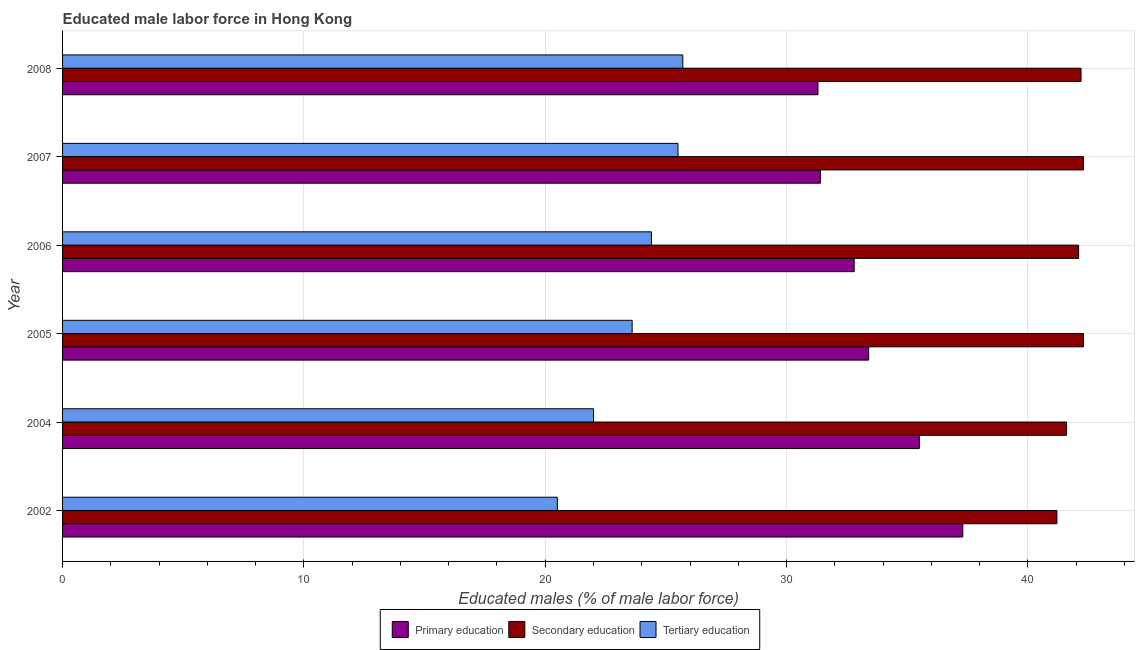How many different coloured bars are there?
Keep it short and to the point. 3. How many bars are there on the 5th tick from the top?
Offer a terse response. 3. How many bars are there on the 5th tick from the bottom?
Your answer should be compact. 3. What is the percentage of male labor force who received primary education in 2007?
Offer a terse response. 31.4. Across all years, what is the maximum percentage of male labor force who received primary education?
Ensure brevity in your answer.  37.3. Across all years, what is the minimum percentage of male labor force who received secondary education?
Provide a short and direct response. 41.2. In which year was the percentage of male labor force who received secondary education maximum?
Offer a very short reply. 2005. In which year was the percentage of male labor force who received primary education minimum?
Ensure brevity in your answer.  2008. What is the total percentage of male labor force who received secondary education in the graph?
Provide a short and direct response. 251.7. What is the difference between the percentage of male labor force who received tertiary education in 2002 and that in 2007?
Your answer should be compact. -5. What is the difference between the percentage of male labor force who received secondary education in 2004 and the percentage of male labor force who received tertiary education in 2006?
Your answer should be compact. 17.2. What is the average percentage of male labor force who received tertiary education per year?
Your answer should be compact. 23.62. In the year 2004, what is the difference between the percentage of male labor force who received primary education and percentage of male labor force who received secondary education?
Give a very brief answer. -6.1. In how many years, is the percentage of male labor force who received secondary education greater than 30 %?
Provide a succinct answer. 6. What is the ratio of the percentage of male labor force who received primary education in 2005 to that in 2007?
Give a very brief answer. 1.06. Is the percentage of male labor force who received tertiary education in 2005 less than that in 2007?
Provide a short and direct response. Yes. What is the difference between the highest and the lowest percentage of male labor force who received secondary education?
Ensure brevity in your answer.  1.1. In how many years, is the percentage of male labor force who received primary education greater than the average percentage of male labor force who received primary education taken over all years?
Keep it short and to the point. 2. What does the 2nd bar from the bottom in 2008 represents?
Offer a very short reply. Secondary education. Is it the case that in every year, the sum of the percentage of male labor force who received primary education and percentage of male labor force who received secondary education is greater than the percentage of male labor force who received tertiary education?
Offer a terse response. Yes. How many bars are there?
Give a very brief answer. 18. Are all the bars in the graph horizontal?
Give a very brief answer. Yes. How many years are there in the graph?
Your answer should be very brief. 6. What is the difference between two consecutive major ticks on the X-axis?
Offer a very short reply. 10. Are the values on the major ticks of X-axis written in scientific E-notation?
Keep it short and to the point. No. Does the graph contain grids?
Provide a succinct answer. Yes. How many legend labels are there?
Keep it short and to the point. 3. How are the legend labels stacked?
Provide a succinct answer. Horizontal. What is the title of the graph?
Your response must be concise. Educated male labor force in Hong Kong. Does "Ages 20-60" appear as one of the legend labels in the graph?
Your response must be concise. No. What is the label or title of the X-axis?
Offer a terse response. Educated males (% of male labor force). What is the Educated males (% of male labor force) in Primary education in 2002?
Provide a short and direct response. 37.3. What is the Educated males (% of male labor force) in Secondary education in 2002?
Provide a short and direct response. 41.2. What is the Educated males (% of male labor force) in Primary education in 2004?
Provide a succinct answer. 35.5. What is the Educated males (% of male labor force) in Secondary education in 2004?
Your response must be concise. 41.6. What is the Educated males (% of male labor force) in Primary education in 2005?
Keep it short and to the point. 33.4. What is the Educated males (% of male labor force) of Secondary education in 2005?
Your response must be concise. 42.3. What is the Educated males (% of male labor force) in Tertiary education in 2005?
Give a very brief answer. 23.6. What is the Educated males (% of male labor force) in Primary education in 2006?
Your answer should be compact. 32.8. What is the Educated males (% of male labor force) of Secondary education in 2006?
Ensure brevity in your answer.  42.1. What is the Educated males (% of male labor force) in Tertiary education in 2006?
Provide a short and direct response. 24.4. What is the Educated males (% of male labor force) of Primary education in 2007?
Make the answer very short. 31.4. What is the Educated males (% of male labor force) of Secondary education in 2007?
Offer a terse response. 42.3. What is the Educated males (% of male labor force) in Tertiary education in 2007?
Your response must be concise. 25.5. What is the Educated males (% of male labor force) in Primary education in 2008?
Give a very brief answer. 31.3. What is the Educated males (% of male labor force) of Secondary education in 2008?
Make the answer very short. 42.2. What is the Educated males (% of male labor force) in Tertiary education in 2008?
Provide a succinct answer. 25.7. Across all years, what is the maximum Educated males (% of male labor force) in Primary education?
Your answer should be very brief. 37.3. Across all years, what is the maximum Educated males (% of male labor force) in Secondary education?
Your answer should be compact. 42.3. Across all years, what is the maximum Educated males (% of male labor force) of Tertiary education?
Your response must be concise. 25.7. Across all years, what is the minimum Educated males (% of male labor force) of Primary education?
Your answer should be compact. 31.3. Across all years, what is the minimum Educated males (% of male labor force) of Secondary education?
Keep it short and to the point. 41.2. Across all years, what is the minimum Educated males (% of male labor force) of Tertiary education?
Keep it short and to the point. 20.5. What is the total Educated males (% of male labor force) of Primary education in the graph?
Offer a very short reply. 201.7. What is the total Educated males (% of male labor force) of Secondary education in the graph?
Provide a succinct answer. 251.7. What is the total Educated males (% of male labor force) in Tertiary education in the graph?
Offer a very short reply. 141.7. What is the difference between the Educated males (% of male labor force) in Primary education in 2002 and that in 2004?
Your response must be concise. 1.8. What is the difference between the Educated males (% of male labor force) in Secondary education in 2002 and that in 2006?
Provide a short and direct response. -0.9. What is the difference between the Educated males (% of male labor force) in Primary education in 2002 and that in 2007?
Your answer should be very brief. 5.9. What is the difference between the Educated males (% of male labor force) of Secondary education in 2002 and that in 2007?
Provide a short and direct response. -1.1. What is the difference between the Educated males (% of male labor force) in Primary education in 2002 and that in 2008?
Keep it short and to the point. 6. What is the difference between the Educated males (% of male labor force) in Primary education in 2004 and that in 2005?
Give a very brief answer. 2.1. What is the difference between the Educated males (% of male labor force) of Secondary education in 2004 and that in 2005?
Ensure brevity in your answer.  -0.7. What is the difference between the Educated males (% of male labor force) in Primary education in 2004 and that in 2006?
Provide a short and direct response. 2.7. What is the difference between the Educated males (% of male labor force) in Primary education in 2004 and that in 2007?
Ensure brevity in your answer.  4.1. What is the difference between the Educated males (% of male labor force) in Secondary education in 2004 and that in 2007?
Ensure brevity in your answer.  -0.7. What is the difference between the Educated males (% of male labor force) in Secondary education in 2004 and that in 2008?
Provide a succinct answer. -0.6. What is the difference between the Educated males (% of male labor force) of Secondary education in 2005 and that in 2006?
Offer a terse response. 0.2. What is the difference between the Educated males (% of male labor force) in Tertiary education in 2005 and that in 2006?
Provide a short and direct response. -0.8. What is the difference between the Educated males (% of male labor force) of Tertiary education in 2005 and that in 2007?
Make the answer very short. -1.9. What is the difference between the Educated males (% of male labor force) of Primary education in 2005 and that in 2008?
Your answer should be compact. 2.1. What is the difference between the Educated males (% of male labor force) in Secondary education in 2005 and that in 2008?
Your response must be concise. 0.1. What is the difference between the Educated males (% of male labor force) in Primary education in 2006 and that in 2007?
Your answer should be compact. 1.4. What is the difference between the Educated males (% of male labor force) in Secondary education in 2006 and that in 2007?
Offer a terse response. -0.2. What is the difference between the Educated males (% of male labor force) in Tertiary education in 2006 and that in 2007?
Give a very brief answer. -1.1. What is the difference between the Educated males (% of male labor force) of Secondary education in 2006 and that in 2008?
Ensure brevity in your answer.  -0.1. What is the difference between the Educated males (% of male labor force) of Tertiary education in 2006 and that in 2008?
Provide a short and direct response. -1.3. What is the difference between the Educated males (% of male labor force) of Secondary education in 2007 and that in 2008?
Your answer should be compact. 0.1. What is the difference between the Educated males (% of male labor force) in Primary education in 2002 and the Educated males (% of male labor force) in Secondary education in 2004?
Give a very brief answer. -4.3. What is the difference between the Educated males (% of male labor force) of Primary education in 2002 and the Educated males (% of male labor force) of Tertiary education in 2004?
Provide a short and direct response. 15.3. What is the difference between the Educated males (% of male labor force) of Secondary education in 2002 and the Educated males (% of male labor force) of Tertiary education in 2004?
Keep it short and to the point. 19.2. What is the difference between the Educated males (% of male labor force) in Primary education in 2002 and the Educated males (% of male labor force) in Secondary education in 2005?
Your answer should be compact. -5. What is the difference between the Educated males (% of male labor force) of Primary education in 2002 and the Educated males (% of male labor force) of Secondary education in 2006?
Keep it short and to the point. -4.8. What is the difference between the Educated males (% of male labor force) of Secondary education in 2002 and the Educated males (% of male labor force) of Tertiary education in 2006?
Your answer should be compact. 16.8. What is the difference between the Educated males (% of male labor force) in Primary education in 2002 and the Educated males (% of male labor force) in Secondary education in 2007?
Offer a terse response. -5. What is the difference between the Educated males (% of male labor force) of Secondary education in 2002 and the Educated males (% of male labor force) of Tertiary education in 2007?
Provide a succinct answer. 15.7. What is the difference between the Educated males (% of male labor force) of Secondary education in 2002 and the Educated males (% of male labor force) of Tertiary education in 2008?
Your answer should be very brief. 15.5. What is the difference between the Educated males (% of male labor force) in Primary education in 2004 and the Educated males (% of male labor force) in Secondary education in 2005?
Give a very brief answer. -6.8. What is the difference between the Educated males (% of male labor force) of Secondary education in 2004 and the Educated males (% of male labor force) of Tertiary education in 2005?
Keep it short and to the point. 18. What is the difference between the Educated males (% of male labor force) in Primary education in 2004 and the Educated males (% of male labor force) in Secondary education in 2007?
Provide a succinct answer. -6.8. What is the difference between the Educated males (% of male labor force) in Secondary education in 2004 and the Educated males (% of male labor force) in Tertiary education in 2007?
Keep it short and to the point. 16.1. What is the difference between the Educated males (% of male labor force) in Primary education in 2004 and the Educated males (% of male labor force) in Secondary education in 2008?
Give a very brief answer. -6.7. What is the difference between the Educated males (% of male labor force) in Secondary education in 2004 and the Educated males (% of male labor force) in Tertiary education in 2008?
Your response must be concise. 15.9. What is the difference between the Educated males (% of male labor force) of Primary education in 2005 and the Educated males (% of male labor force) of Secondary education in 2006?
Offer a very short reply. -8.7. What is the difference between the Educated males (% of male labor force) of Secondary education in 2005 and the Educated males (% of male labor force) of Tertiary education in 2006?
Your answer should be compact. 17.9. What is the difference between the Educated males (% of male labor force) of Primary education in 2005 and the Educated males (% of male labor force) of Secondary education in 2007?
Ensure brevity in your answer.  -8.9. What is the difference between the Educated males (% of male labor force) of Primary education in 2005 and the Educated males (% of male labor force) of Tertiary education in 2007?
Give a very brief answer. 7.9. What is the difference between the Educated males (% of male labor force) of Primary education in 2005 and the Educated males (% of male labor force) of Tertiary education in 2008?
Your answer should be very brief. 7.7. What is the difference between the Educated males (% of male labor force) of Secondary education in 2005 and the Educated males (% of male labor force) of Tertiary education in 2008?
Your response must be concise. 16.6. What is the difference between the Educated males (% of male labor force) in Primary education in 2006 and the Educated males (% of male labor force) in Secondary education in 2007?
Offer a very short reply. -9.5. What is the difference between the Educated males (% of male labor force) in Primary education in 2006 and the Educated males (% of male labor force) in Tertiary education in 2008?
Offer a very short reply. 7.1. What is the difference between the Educated males (% of male labor force) in Secondary education in 2006 and the Educated males (% of male labor force) in Tertiary education in 2008?
Provide a succinct answer. 16.4. What is the difference between the Educated males (% of male labor force) in Primary education in 2007 and the Educated males (% of male labor force) in Secondary education in 2008?
Your response must be concise. -10.8. What is the difference between the Educated males (% of male labor force) of Secondary education in 2007 and the Educated males (% of male labor force) of Tertiary education in 2008?
Your answer should be very brief. 16.6. What is the average Educated males (% of male labor force) in Primary education per year?
Your response must be concise. 33.62. What is the average Educated males (% of male labor force) in Secondary education per year?
Give a very brief answer. 41.95. What is the average Educated males (% of male labor force) of Tertiary education per year?
Offer a terse response. 23.62. In the year 2002, what is the difference between the Educated males (% of male labor force) in Primary education and Educated males (% of male labor force) in Secondary education?
Your response must be concise. -3.9. In the year 2002, what is the difference between the Educated males (% of male labor force) in Secondary education and Educated males (% of male labor force) in Tertiary education?
Your answer should be compact. 20.7. In the year 2004, what is the difference between the Educated males (% of male labor force) in Primary education and Educated males (% of male labor force) in Tertiary education?
Keep it short and to the point. 13.5. In the year 2004, what is the difference between the Educated males (% of male labor force) in Secondary education and Educated males (% of male labor force) in Tertiary education?
Your answer should be very brief. 19.6. In the year 2005, what is the difference between the Educated males (% of male labor force) of Primary education and Educated males (% of male labor force) of Secondary education?
Ensure brevity in your answer.  -8.9. In the year 2005, what is the difference between the Educated males (% of male labor force) of Primary education and Educated males (% of male labor force) of Tertiary education?
Provide a short and direct response. 9.8. In the year 2006, what is the difference between the Educated males (% of male labor force) in Primary education and Educated males (% of male labor force) in Secondary education?
Give a very brief answer. -9.3. In the year 2006, what is the difference between the Educated males (% of male labor force) of Primary education and Educated males (% of male labor force) of Tertiary education?
Your response must be concise. 8.4. In the year 2007, what is the difference between the Educated males (% of male labor force) of Primary education and Educated males (% of male labor force) of Secondary education?
Provide a succinct answer. -10.9. In the year 2007, what is the difference between the Educated males (% of male labor force) of Secondary education and Educated males (% of male labor force) of Tertiary education?
Ensure brevity in your answer.  16.8. What is the ratio of the Educated males (% of male labor force) in Primary education in 2002 to that in 2004?
Ensure brevity in your answer.  1.05. What is the ratio of the Educated males (% of male labor force) in Tertiary education in 2002 to that in 2004?
Provide a short and direct response. 0.93. What is the ratio of the Educated males (% of male labor force) in Primary education in 2002 to that in 2005?
Make the answer very short. 1.12. What is the ratio of the Educated males (% of male labor force) of Secondary education in 2002 to that in 2005?
Give a very brief answer. 0.97. What is the ratio of the Educated males (% of male labor force) of Tertiary education in 2002 to that in 2005?
Your response must be concise. 0.87. What is the ratio of the Educated males (% of male labor force) of Primary education in 2002 to that in 2006?
Keep it short and to the point. 1.14. What is the ratio of the Educated males (% of male labor force) of Secondary education in 2002 to that in 2006?
Your answer should be compact. 0.98. What is the ratio of the Educated males (% of male labor force) of Tertiary education in 2002 to that in 2006?
Provide a succinct answer. 0.84. What is the ratio of the Educated males (% of male labor force) in Primary education in 2002 to that in 2007?
Provide a short and direct response. 1.19. What is the ratio of the Educated males (% of male labor force) in Tertiary education in 2002 to that in 2007?
Your answer should be very brief. 0.8. What is the ratio of the Educated males (% of male labor force) of Primary education in 2002 to that in 2008?
Offer a terse response. 1.19. What is the ratio of the Educated males (% of male labor force) of Secondary education in 2002 to that in 2008?
Offer a very short reply. 0.98. What is the ratio of the Educated males (% of male labor force) in Tertiary education in 2002 to that in 2008?
Provide a short and direct response. 0.8. What is the ratio of the Educated males (% of male labor force) in Primary education in 2004 to that in 2005?
Your response must be concise. 1.06. What is the ratio of the Educated males (% of male labor force) in Secondary education in 2004 to that in 2005?
Provide a short and direct response. 0.98. What is the ratio of the Educated males (% of male labor force) of Tertiary education in 2004 to that in 2005?
Keep it short and to the point. 0.93. What is the ratio of the Educated males (% of male labor force) of Primary education in 2004 to that in 2006?
Your answer should be compact. 1.08. What is the ratio of the Educated males (% of male labor force) of Secondary education in 2004 to that in 2006?
Your answer should be very brief. 0.99. What is the ratio of the Educated males (% of male labor force) in Tertiary education in 2004 to that in 2006?
Your answer should be compact. 0.9. What is the ratio of the Educated males (% of male labor force) of Primary education in 2004 to that in 2007?
Make the answer very short. 1.13. What is the ratio of the Educated males (% of male labor force) of Secondary education in 2004 to that in 2007?
Provide a short and direct response. 0.98. What is the ratio of the Educated males (% of male labor force) of Tertiary education in 2004 to that in 2007?
Your response must be concise. 0.86. What is the ratio of the Educated males (% of male labor force) in Primary education in 2004 to that in 2008?
Give a very brief answer. 1.13. What is the ratio of the Educated males (% of male labor force) in Secondary education in 2004 to that in 2008?
Your response must be concise. 0.99. What is the ratio of the Educated males (% of male labor force) in Tertiary education in 2004 to that in 2008?
Ensure brevity in your answer.  0.86. What is the ratio of the Educated males (% of male labor force) of Primary education in 2005 to that in 2006?
Your answer should be very brief. 1.02. What is the ratio of the Educated males (% of male labor force) in Tertiary education in 2005 to that in 2006?
Offer a terse response. 0.97. What is the ratio of the Educated males (% of male labor force) in Primary education in 2005 to that in 2007?
Provide a short and direct response. 1.06. What is the ratio of the Educated males (% of male labor force) of Secondary education in 2005 to that in 2007?
Keep it short and to the point. 1. What is the ratio of the Educated males (% of male labor force) in Tertiary education in 2005 to that in 2007?
Give a very brief answer. 0.93. What is the ratio of the Educated males (% of male labor force) of Primary education in 2005 to that in 2008?
Your answer should be compact. 1.07. What is the ratio of the Educated males (% of male labor force) of Secondary education in 2005 to that in 2008?
Offer a very short reply. 1. What is the ratio of the Educated males (% of male labor force) in Tertiary education in 2005 to that in 2008?
Provide a short and direct response. 0.92. What is the ratio of the Educated males (% of male labor force) of Primary education in 2006 to that in 2007?
Your answer should be compact. 1.04. What is the ratio of the Educated males (% of male labor force) of Tertiary education in 2006 to that in 2007?
Your response must be concise. 0.96. What is the ratio of the Educated males (% of male labor force) of Primary education in 2006 to that in 2008?
Make the answer very short. 1.05. What is the ratio of the Educated males (% of male labor force) in Secondary education in 2006 to that in 2008?
Provide a succinct answer. 1. What is the ratio of the Educated males (% of male labor force) in Tertiary education in 2006 to that in 2008?
Provide a short and direct response. 0.95. What is the ratio of the Educated males (% of male labor force) in Primary education in 2007 to that in 2008?
Offer a very short reply. 1. What is the difference between the highest and the second highest Educated males (% of male labor force) in Secondary education?
Ensure brevity in your answer.  0. 